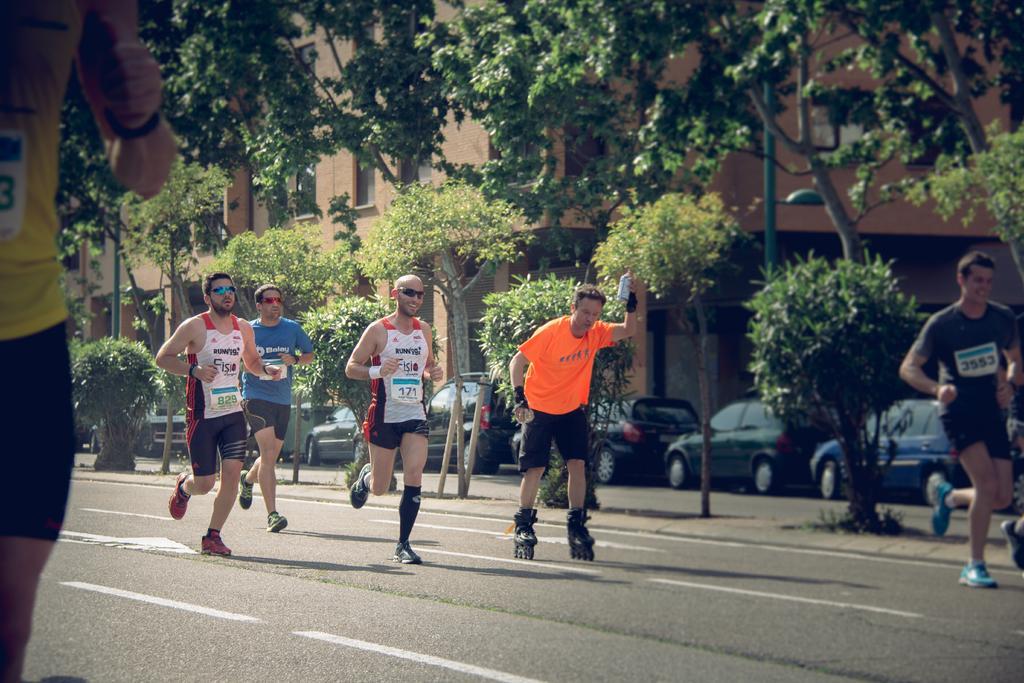Please provide a concise description of this image. In this picture I can see a man is skating on the road, beside him few men are running on the road. In the background there are trees, vehicles and buildings. 